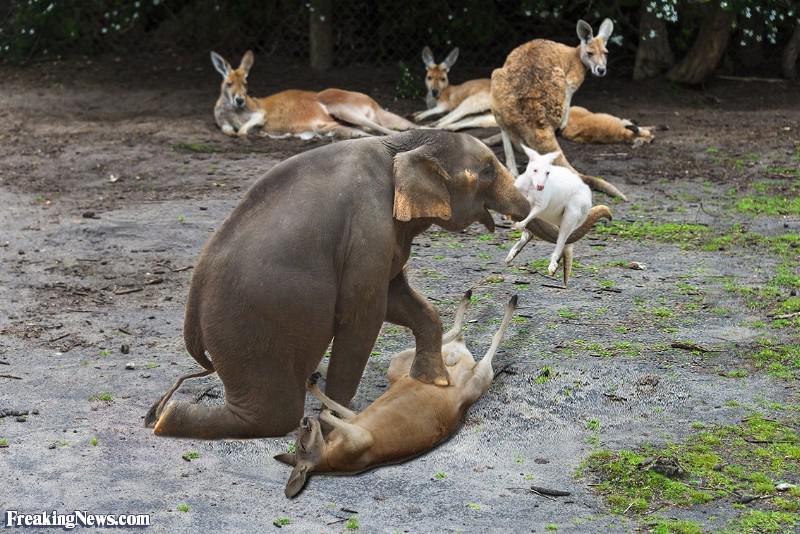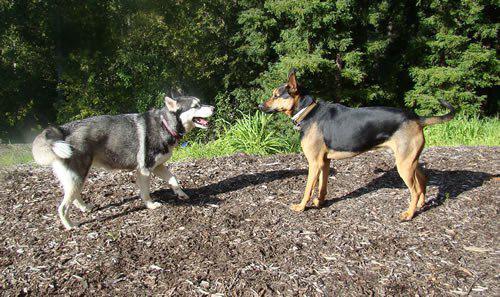The first image is the image on the left, the second image is the image on the right. Given the left and right images, does the statement "In at least one image there is a single male in camo clothes holding a hunting gun near the dead brown fox." hold true? Answer yes or no. No. The first image is the image on the left, the second image is the image on the right. Given the left and right images, does the statement "There is at least two canines in the right image." hold true? Answer yes or no. Yes. 